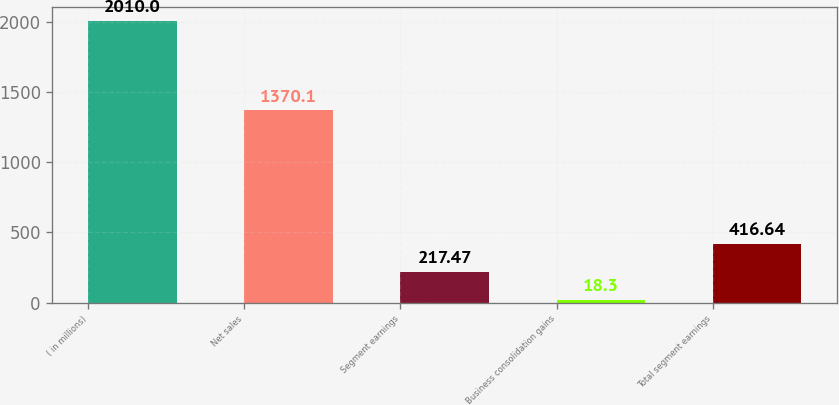Convert chart to OTSL. <chart><loc_0><loc_0><loc_500><loc_500><bar_chart><fcel>( in millions)<fcel>Net sales<fcel>Segment earnings<fcel>Business consolidation gains<fcel>Total segment earnings<nl><fcel>2010<fcel>1370.1<fcel>217.47<fcel>18.3<fcel>416.64<nl></chart> 